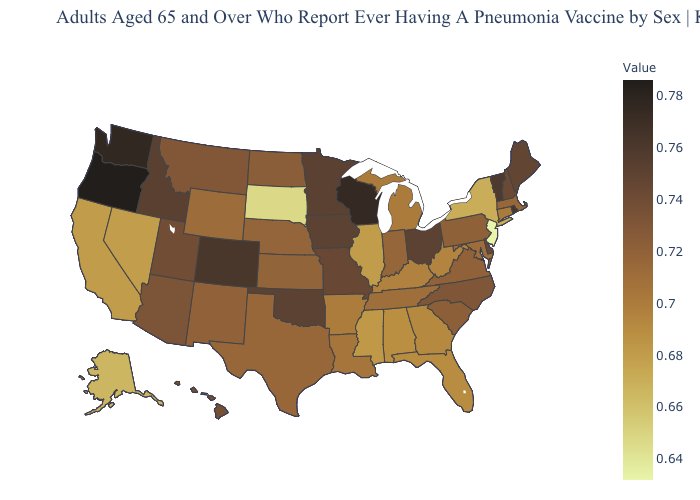Which states have the lowest value in the USA?
Short answer required. New Jersey. Does Oregon have the highest value in the USA?
Short answer required. Yes. Among the states that border Vermont , does New York have the lowest value?
Answer briefly. Yes. Among the states that border Florida , does Georgia have the lowest value?
Keep it brief. No. Which states have the lowest value in the USA?
Keep it brief. New Jersey. Among the states that border Illinois , does Wisconsin have the highest value?
Keep it brief. Yes. Among the states that border Kansas , does Colorado have the lowest value?
Give a very brief answer. No. Which states have the lowest value in the USA?
Keep it brief. New Jersey. Which states have the highest value in the USA?
Concise answer only. Oregon. Which states hav the highest value in the West?
Short answer required. Oregon. 